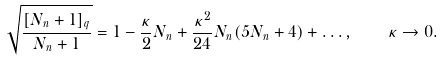Convert formula to latex. <formula><loc_0><loc_0><loc_500><loc_500>\sqrt { \frac { [ N _ { n } + 1 ] _ { q } } { N _ { n } + 1 } } = 1 - \frac { \kappa } 2 N _ { n } + \frac { \kappa ^ { 2 } } { 2 4 } N _ { n } ( 5 N _ { n } + 4 ) + \dots , \quad \kappa \to 0 .</formula> 